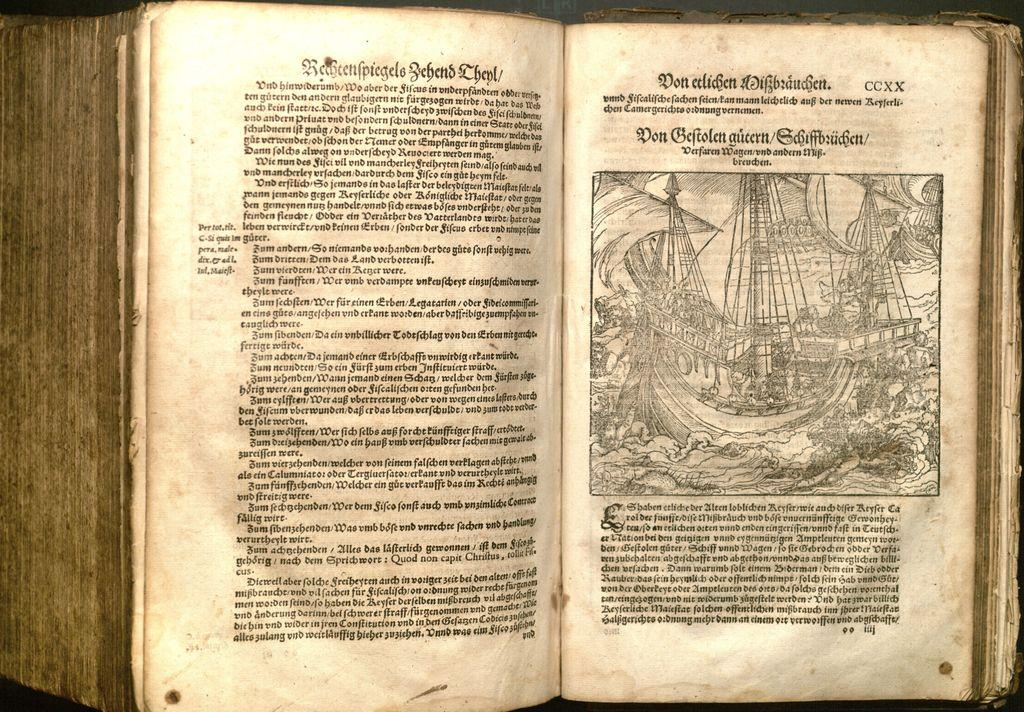<image>
Describe the image concisely. A book is open to a page showing a ship sailing on page CCXX. 